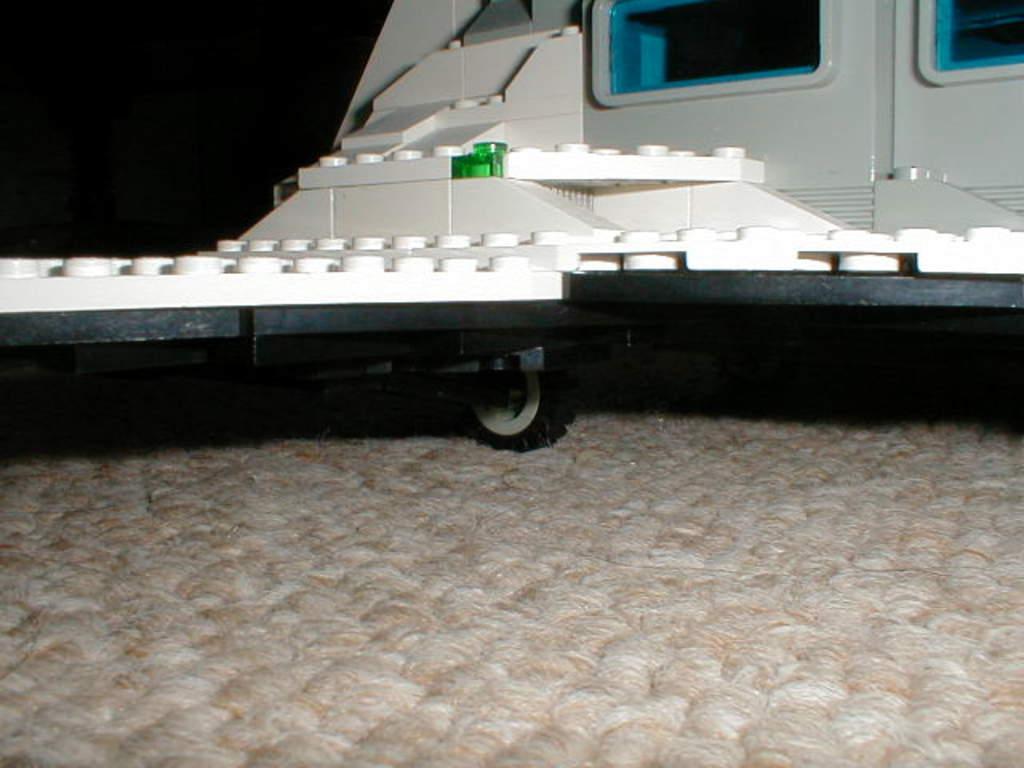Please provide a concise description of this image. In this image there is an object towards the top of the image that looks like a vehicle, there is an object towards the bottom of the image that looks like a mat, the background of the image is dark. 